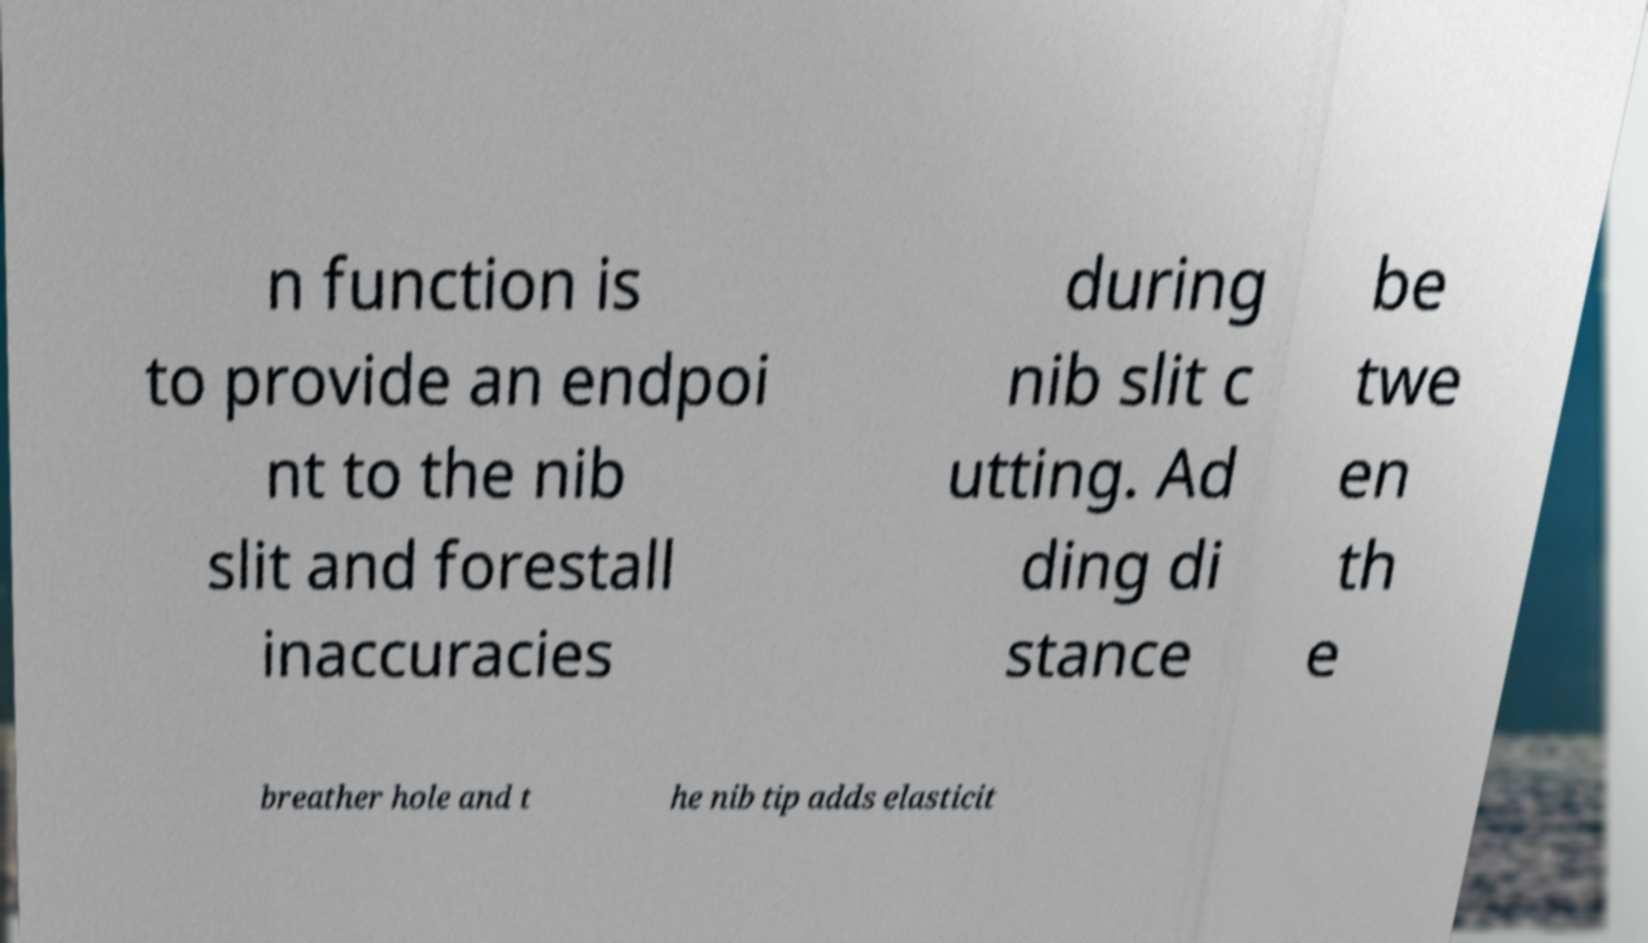Could you extract and type out the text from this image? n function is to provide an endpoi nt to the nib slit and forestall inaccuracies during nib slit c utting. Ad ding di stance be twe en th e breather hole and t he nib tip adds elasticit 